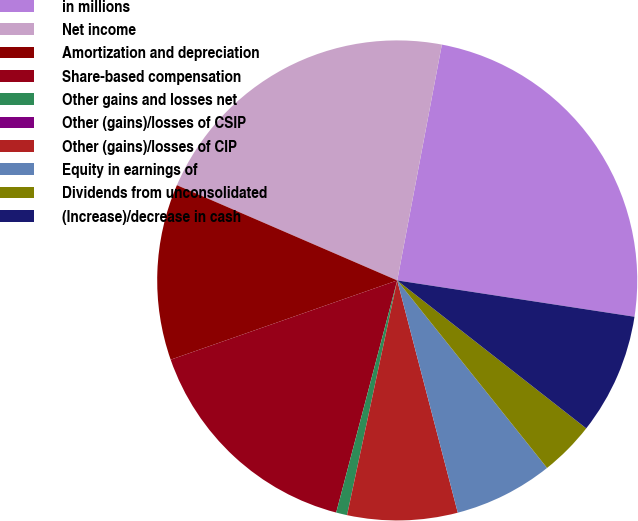<chart> <loc_0><loc_0><loc_500><loc_500><pie_chart><fcel>in millions<fcel>Net income<fcel>Amortization and depreciation<fcel>Share-based compensation<fcel>Other gains and losses net<fcel>Other (gains)/losses of CSIP<fcel>Other (gains)/losses of CIP<fcel>Equity in earnings of<fcel>Dividends from unconsolidated<fcel>(Increase)/decrease in cash<nl><fcel>24.44%<fcel>21.48%<fcel>11.85%<fcel>15.55%<fcel>0.74%<fcel>0.0%<fcel>7.41%<fcel>6.67%<fcel>3.7%<fcel>8.15%<nl></chart> 